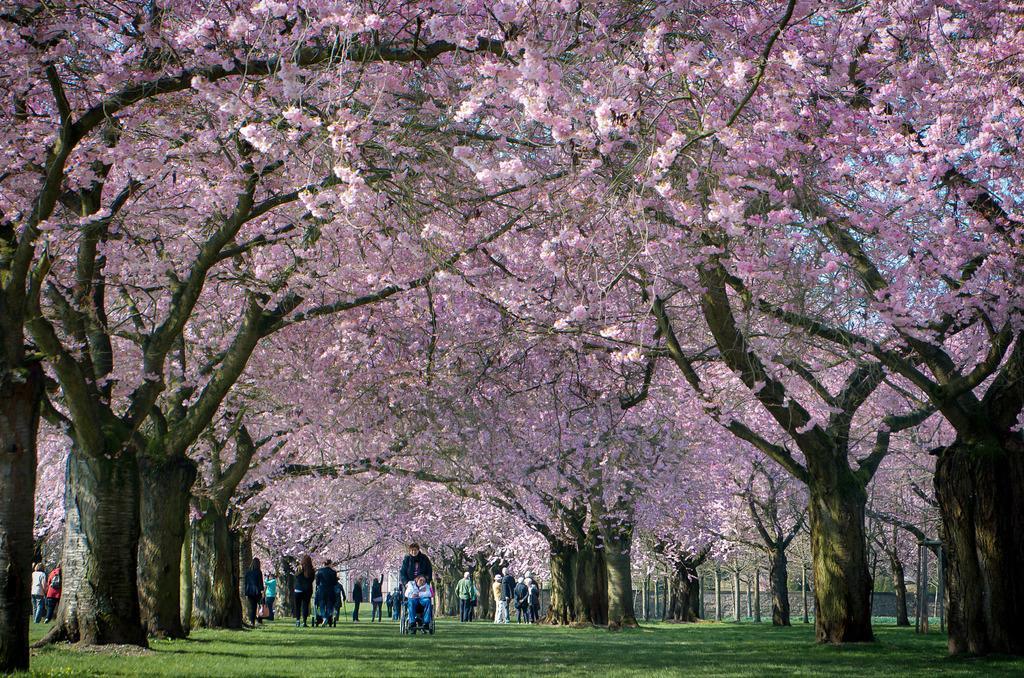Could you give a brief overview of what you see in this image? To the bottom of the image on the ground there is a grass. And in the middle of the image there is a person sitting on the wheelchair. Behind the person there is another person standing. And also in the background there are few people standing. To the left and right side of the image there are many trees with pink leaves. 